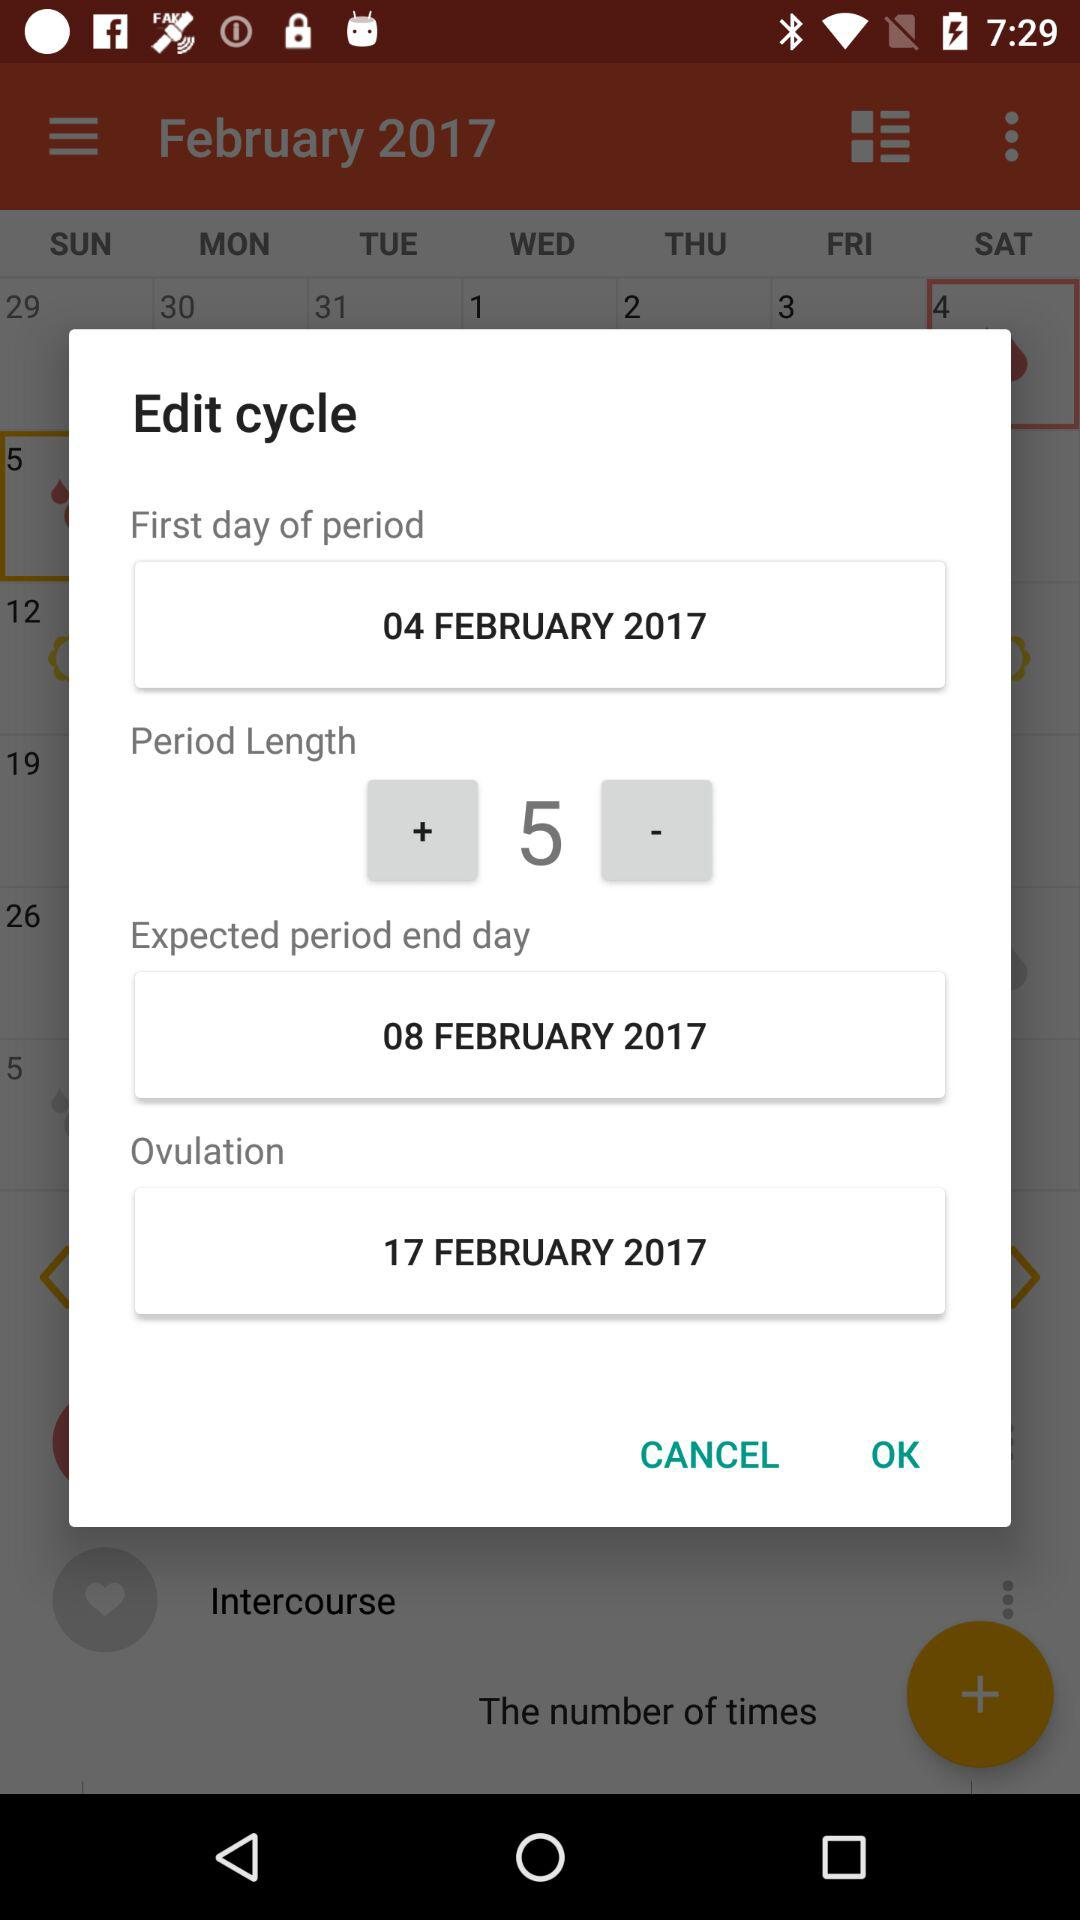What is the length of the period? The length of the period is 5. 